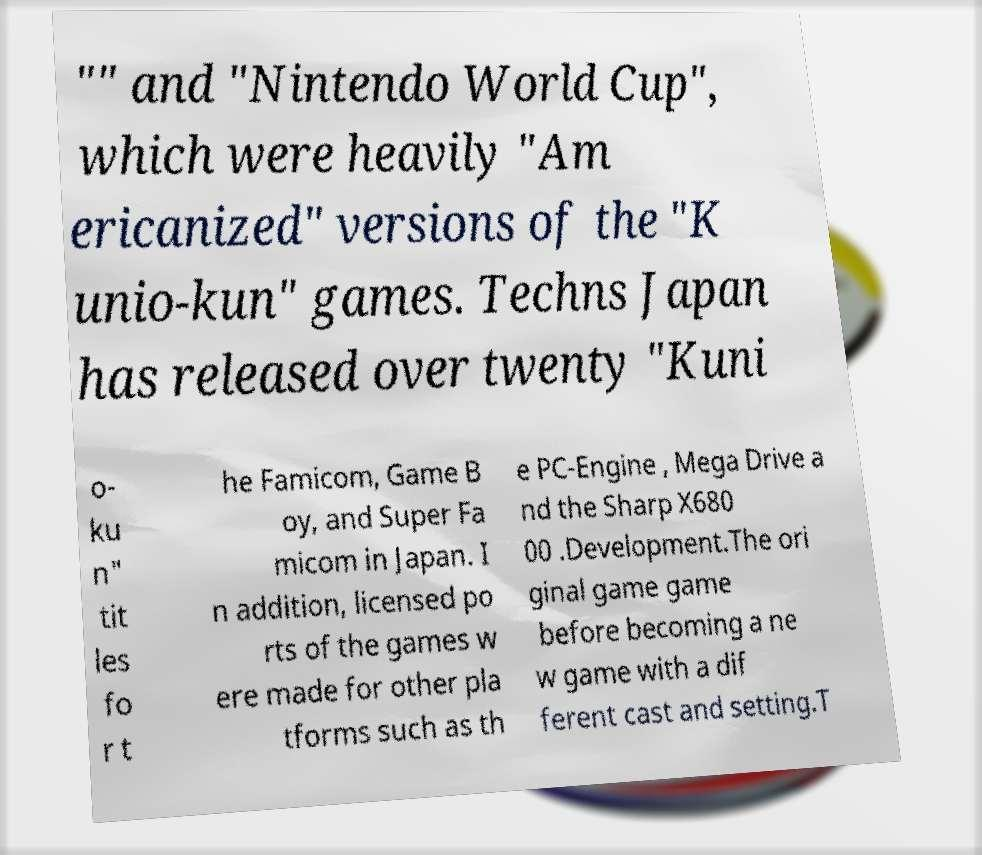Could you extract and type out the text from this image? "" and "Nintendo World Cup", which were heavily "Am ericanized" versions of the "K unio-kun" games. Techns Japan has released over twenty "Kuni o- ku n" tit les fo r t he Famicom, Game B oy, and Super Fa micom in Japan. I n addition, licensed po rts of the games w ere made for other pla tforms such as th e PC-Engine , Mega Drive a nd the Sharp X680 00 .Development.The ori ginal game game before becoming a ne w game with a dif ferent cast and setting.T 